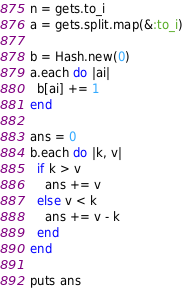Convert code to text. <code><loc_0><loc_0><loc_500><loc_500><_Ruby_>n = gets.to_i
a = gets.split.map(&:to_i)

b = Hash.new(0)
a.each do |ai|
  b[ai] += 1
end

ans = 0
b.each do |k, v|
  if k > v
    ans += v
  else v < k
    ans += v - k
  end
end

puts ans
</code> 